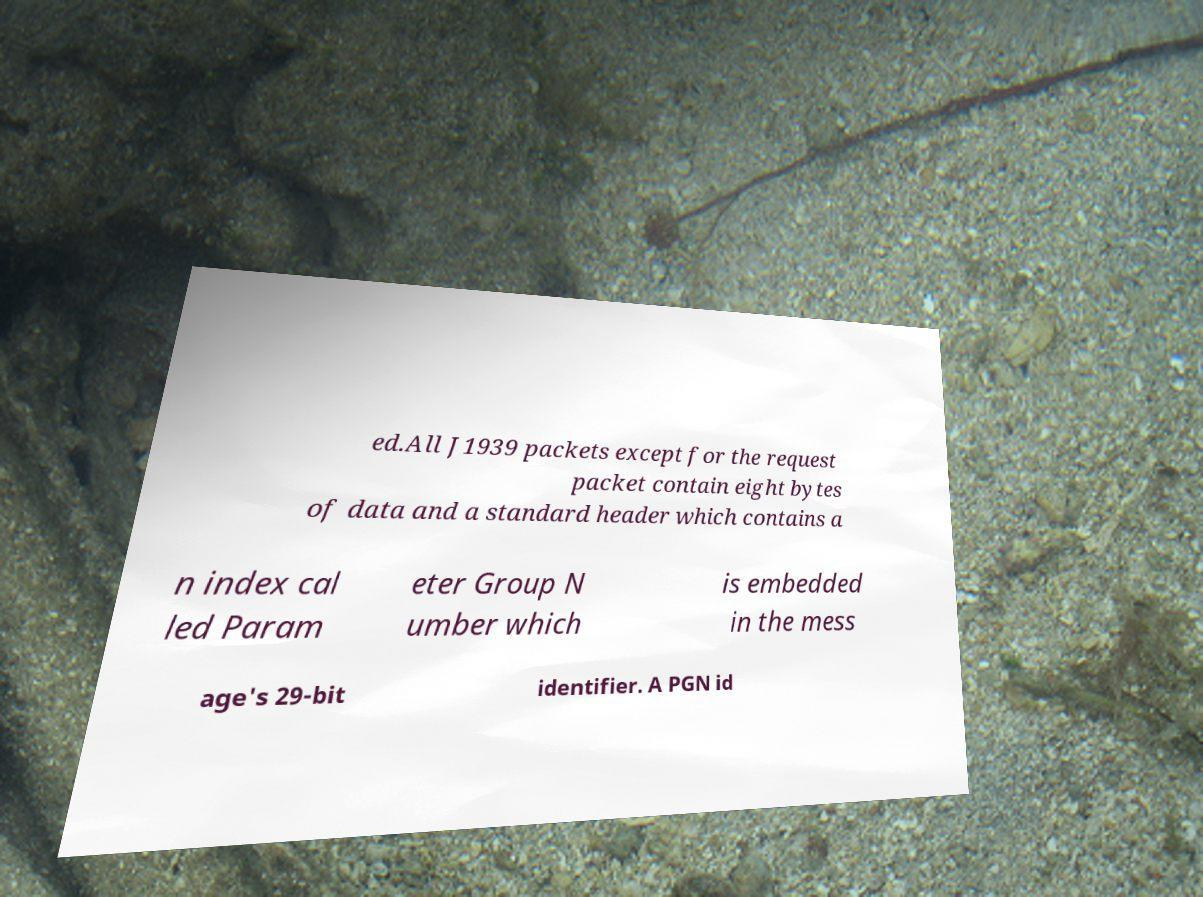What messages or text are displayed in this image? I need them in a readable, typed format. ed.All J1939 packets except for the request packet contain eight bytes of data and a standard header which contains a n index cal led Param eter Group N umber which is embedded in the mess age's 29-bit identifier. A PGN id 